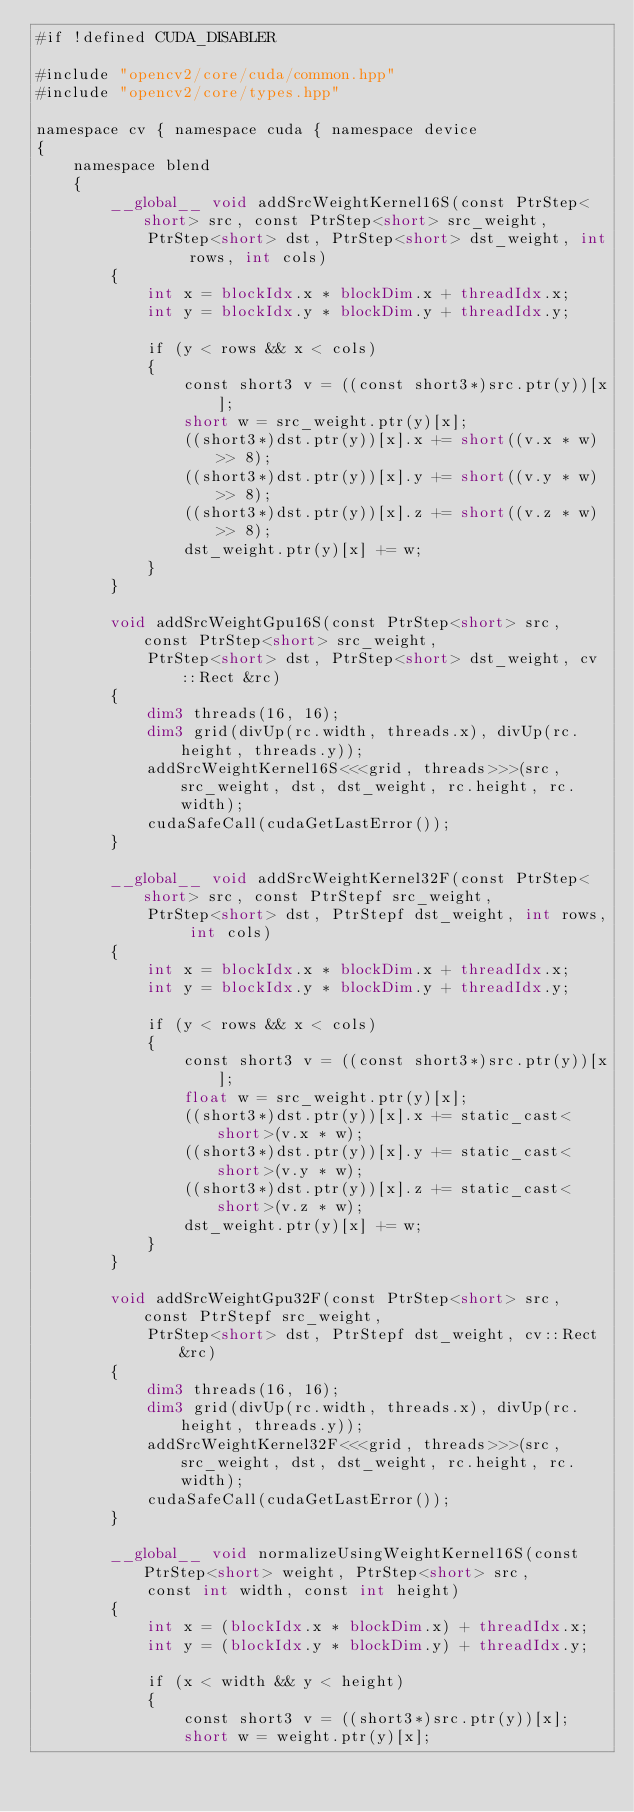<code> <loc_0><loc_0><loc_500><loc_500><_Cuda_>#if !defined CUDA_DISABLER

#include "opencv2/core/cuda/common.hpp"
#include "opencv2/core/types.hpp"

namespace cv { namespace cuda { namespace device
{
    namespace blend
    {
        __global__ void addSrcWeightKernel16S(const PtrStep<short> src, const PtrStep<short> src_weight,
            PtrStep<short> dst, PtrStep<short> dst_weight, int rows, int cols)
        {
            int x = blockIdx.x * blockDim.x + threadIdx.x;
            int y = blockIdx.y * blockDim.y + threadIdx.y;

            if (y < rows && x < cols)
            {
                const short3 v = ((const short3*)src.ptr(y))[x];
                short w = src_weight.ptr(y)[x];
                ((short3*)dst.ptr(y))[x].x += short((v.x * w) >> 8);
                ((short3*)dst.ptr(y))[x].y += short((v.y * w) >> 8);
                ((short3*)dst.ptr(y))[x].z += short((v.z * w) >> 8);
                dst_weight.ptr(y)[x] += w;
            }
        }

        void addSrcWeightGpu16S(const PtrStep<short> src, const PtrStep<short> src_weight,
            PtrStep<short> dst, PtrStep<short> dst_weight, cv::Rect &rc)
        {
            dim3 threads(16, 16);
            dim3 grid(divUp(rc.width, threads.x), divUp(rc.height, threads.y));
            addSrcWeightKernel16S<<<grid, threads>>>(src, src_weight, dst, dst_weight, rc.height, rc.width);
            cudaSafeCall(cudaGetLastError());
        }

        __global__ void addSrcWeightKernel32F(const PtrStep<short> src, const PtrStepf src_weight,
            PtrStep<short> dst, PtrStepf dst_weight, int rows, int cols)
        {
            int x = blockIdx.x * blockDim.x + threadIdx.x;
            int y = blockIdx.y * blockDim.y + threadIdx.y;

            if (y < rows && x < cols)
            {
                const short3 v = ((const short3*)src.ptr(y))[x];
                float w = src_weight.ptr(y)[x];
                ((short3*)dst.ptr(y))[x].x += static_cast<short>(v.x * w);
                ((short3*)dst.ptr(y))[x].y += static_cast<short>(v.y * w);
                ((short3*)dst.ptr(y))[x].z += static_cast<short>(v.z * w);
                dst_weight.ptr(y)[x] += w;
            }
        }

        void addSrcWeightGpu32F(const PtrStep<short> src, const PtrStepf src_weight,
            PtrStep<short> dst, PtrStepf dst_weight, cv::Rect &rc)
        {
            dim3 threads(16, 16);
            dim3 grid(divUp(rc.width, threads.x), divUp(rc.height, threads.y));
            addSrcWeightKernel32F<<<grid, threads>>>(src, src_weight, dst, dst_weight, rc.height, rc.width);
            cudaSafeCall(cudaGetLastError());
        }

        __global__ void normalizeUsingWeightKernel16S(const PtrStep<short> weight, PtrStep<short> src,
            const int width, const int height)
        {
            int x = (blockIdx.x * blockDim.x) + threadIdx.x;
            int y = (blockIdx.y * blockDim.y) + threadIdx.y;

            if (x < width && y < height)
            {
                const short3 v = ((short3*)src.ptr(y))[x];
                short w = weight.ptr(y)[x];</code> 